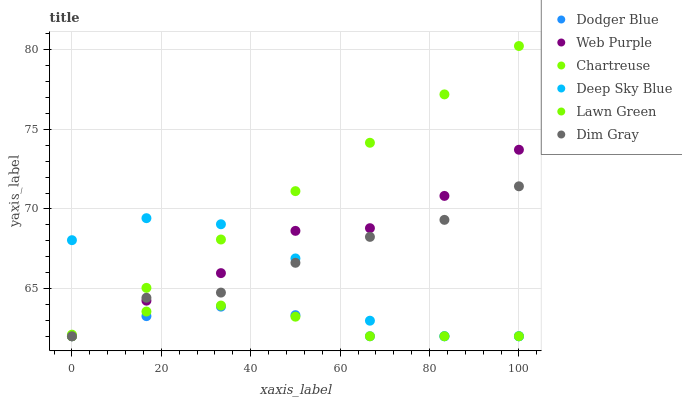Does Dodger Blue have the minimum area under the curve?
Answer yes or no. Yes. Does Chartreuse have the maximum area under the curve?
Answer yes or no. Yes. Does Dim Gray have the minimum area under the curve?
Answer yes or no. No. Does Dim Gray have the maximum area under the curve?
Answer yes or no. No. Is Chartreuse the smoothest?
Answer yes or no. Yes. Is Deep Sky Blue the roughest?
Answer yes or no. Yes. Is Dim Gray the smoothest?
Answer yes or no. No. Is Dim Gray the roughest?
Answer yes or no. No. Does Lawn Green have the lowest value?
Answer yes or no. Yes. Does Chartreuse have the highest value?
Answer yes or no. Yes. Does Dim Gray have the highest value?
Answer yes or no. No. Does Web Purple intersect Deep Sky Blue?
Answer yes or no. Yes. Is Web Purple less than Deep Sky Blue?
Answer yes or no. No. Is Web Purple greater than Deep Sky Blue?
Answer yes or no. No. 